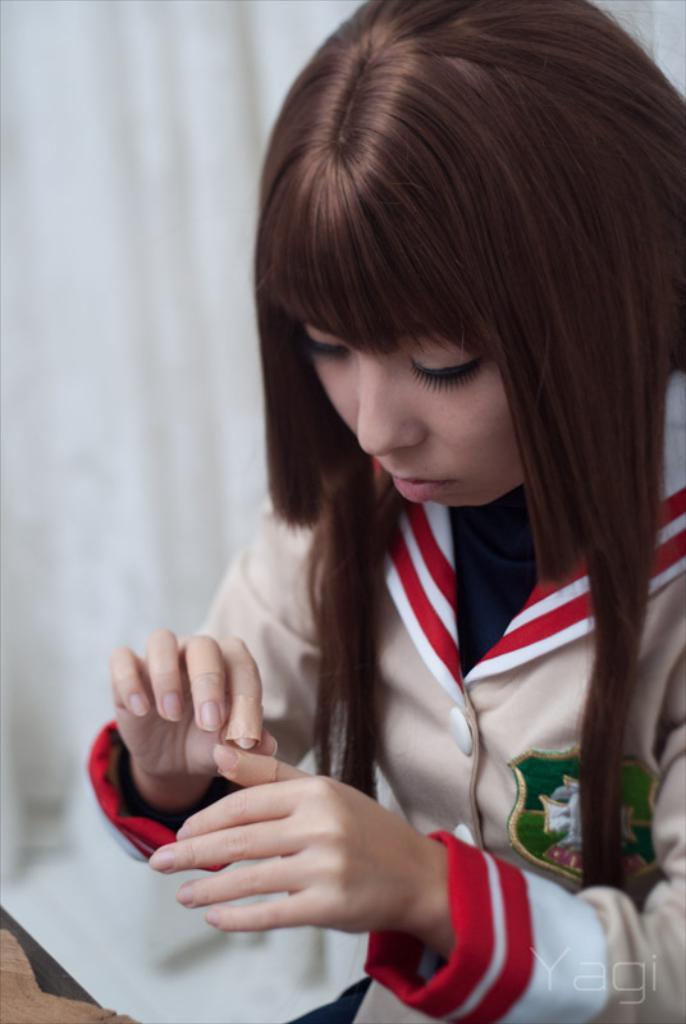Please provide a concise description of this image. In the background we can see a white cloth. In this picture we can see a woman and there are band-aids to her fingers. In the bottom right corner of the picture we can see watermark. 